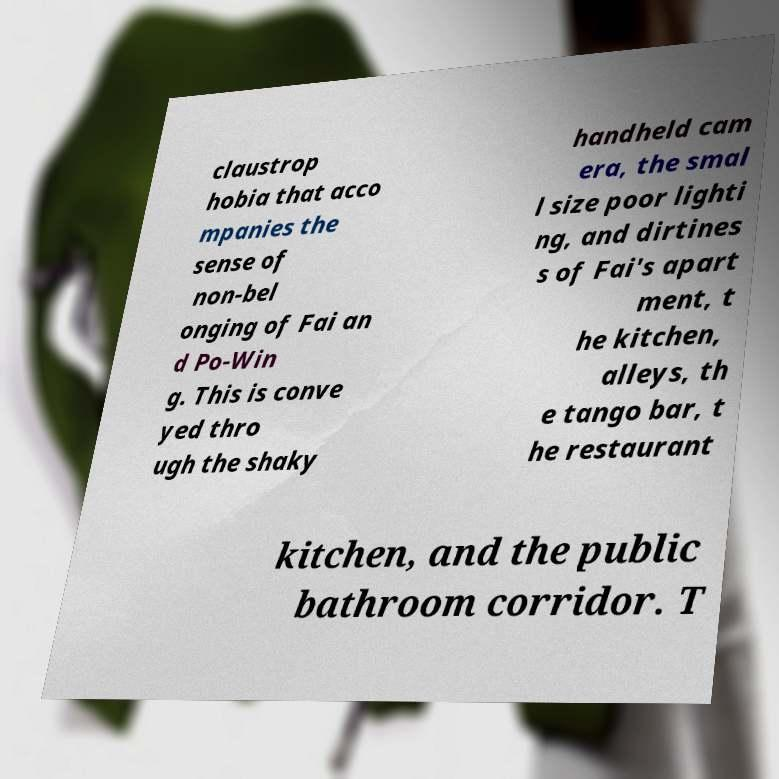Could you assist in decoding the text presented in this image and type it out clearly? claustrop hobia that acco mpanies the sense of non-bel onging of Fai an d Po-Win g. This is conve yed thro ugh the shaky handheld cam era, the smal l size poor lighti ng, and dirtines s of Fai's apart ment, t he kitchen, alleys, th e tango bar, t he restaurant kitchen, and the public bathroom corridor. T 